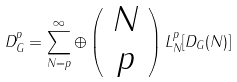<formula> <loc_0><loc_0><loc_500><loc_500>D ^ { p } _ { G } = \sum _ { N = p } ^ { \infty } \oplus \left ( \begin{array} { c } N \\ p \end{array} \right ) L _ { N } ^ { p } [ D _ { G } ( N ) ]</formula> 